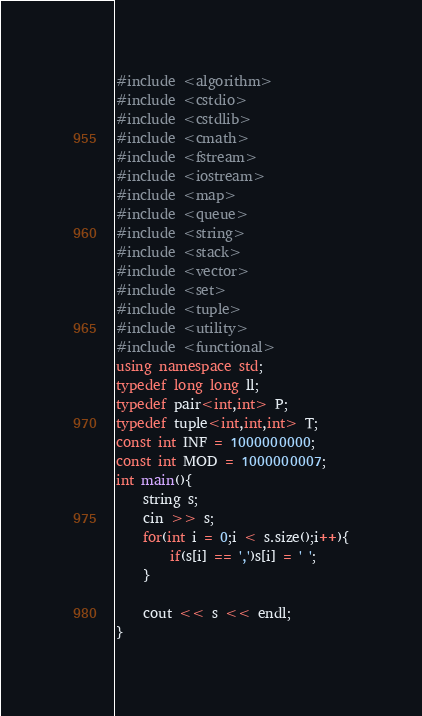Convert code to text. <code><loc_0><loc_0><loc_500><loc_500><_C++_>#include <algorithm>
#include <cstdio>
#include <cstdlib>
#include <cmath>
#include <fstream>
#include <iostream>
#include <map>
#include <queue>
#include <string>
#include <stack>
#include <vector>
#include <set>
#include <tuple>
#include <utility>
#include <functional>
using namespace std;
typedef long long ll;
typedef pair<int,int> P;
typedef tuple<int,int,int> T;
const int INF = 1000000000;
const int MOD = 1000000007;
int main(){
	string s;
	cin >> s;
	for(int i = 0;i < s.size();i++){
		if(s[i] == ',')s[i] = ' ';
	}

	cout << s << endl;
}
</code> 